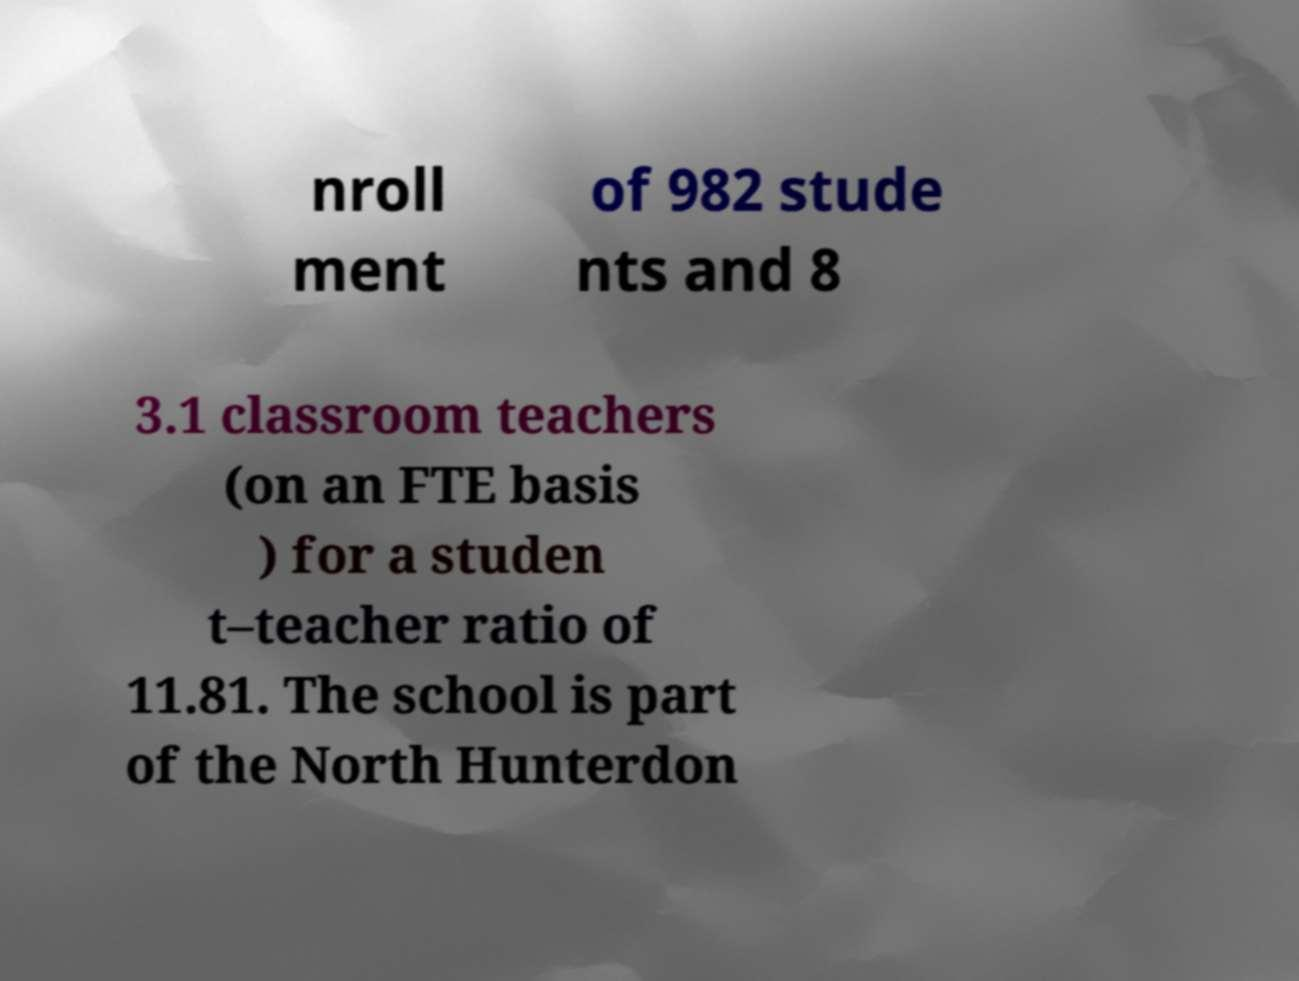What messages or text are displayed in this image? I need them in a readable, typed format. nroll ment of 982 stude nts and 8 3.1 classroom teachers (on an FTE basis ) for a studen t–teacher ratio of 11.81. The school is part of the North Hunterdon 